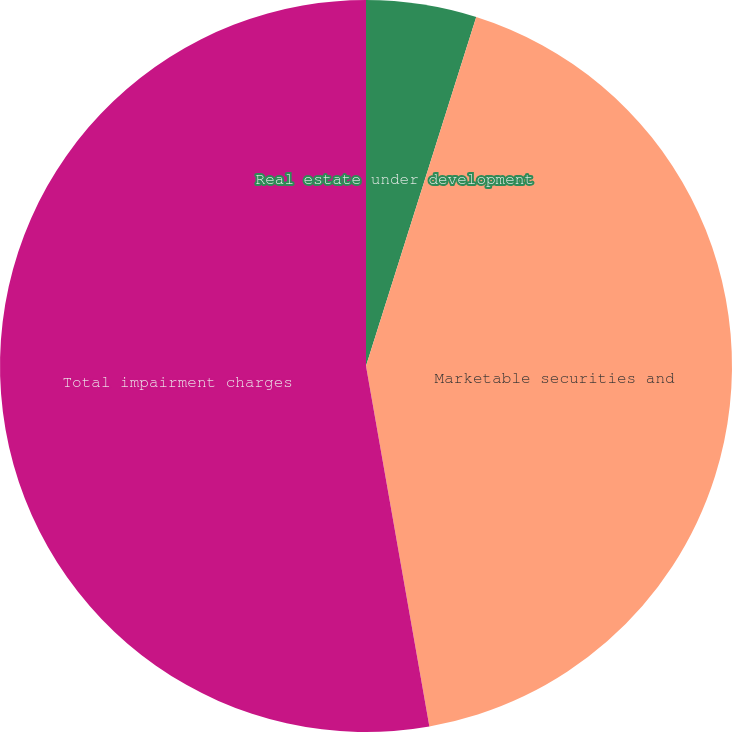Convert chart to OTSL. <chart><loc_0><loc_0><loc_500><loc_500><pie_chart><fcel>Real estate under development<fcel>Marketable securities and<fcel>Total impairment charges<nl><fcel>4.87%<fcel>42.36%<fcel>52.77%<nl></chart> 